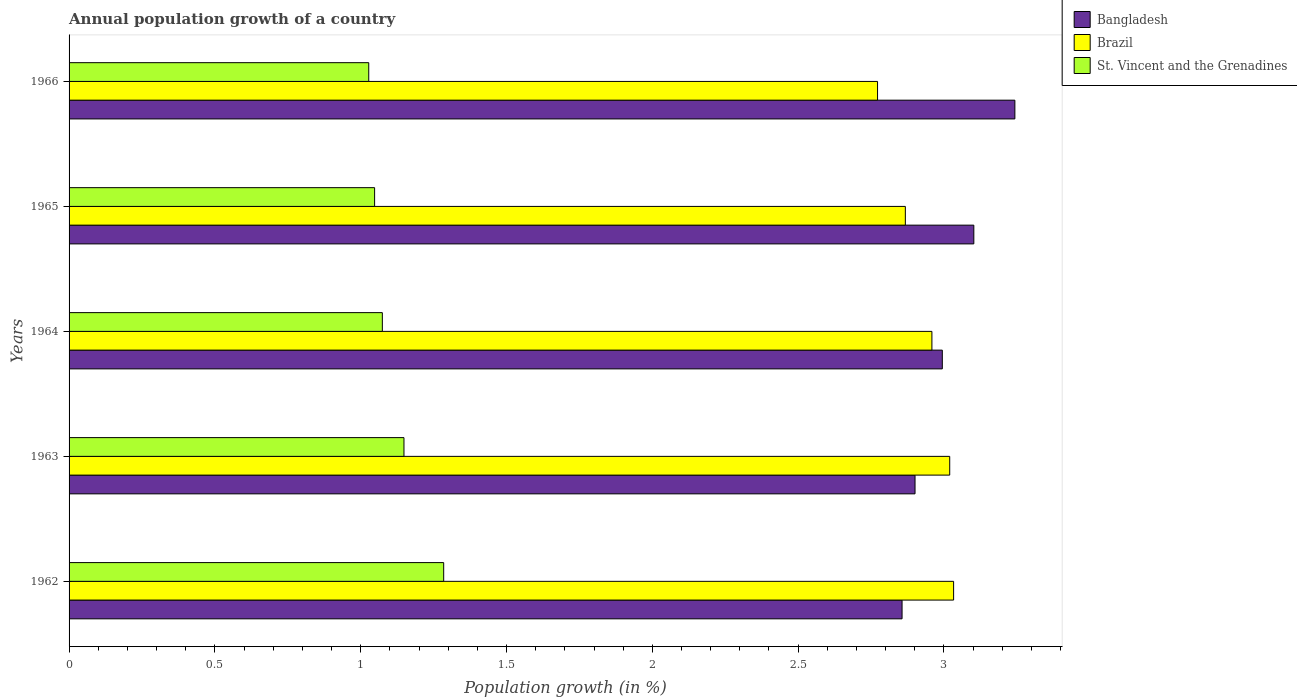How many groups of bars are there?
Keep it short and to the point. 5. Are the number of bars per tick equal to the number of legend labels?
Your answer should be compact. Yes. How many bars are there on the 4th tick from the top?
Your response must be concise. 3. What is the label of the 2nd group of bars from the top?
Give a very brief answer. 1965. In how many cases, is the number of bars for a given year not equal to the number of legend labels?
Keep it short and to the point. 0. What is the annual population growth in Brazil in 1965?
Keep it short and to the point. 2.87. Across all years, what is the maximum annual population growth in Brazil?
Provide a short and direct response. 3.03. Across all years, what is the minimum annual population growth in St. Vincent and the Grenadines?
Provide a succinct answer. 1.03. In which year was the annual population growth in Brazil minimum?
Your answer should be very brief. 1966. What is the total annual population growth in St. Vincent and the Grenadines in the graph?
Your response must be concise. 5.58. What is the difference between the annual population growth in Bangladesh in 1962 and that in 1965?
Make the answer very short. -0.25. What is the difference between the annual population growth in St. Vincent and the Grenadines in 1966 and the annual population growth in Bangladesh in 1963?
Ensure brevity in your answer.  -1.87. What is the average annual population growth in Bangladesh per year?
Offer a very short reply. 3.02. In the year 1962, what is the difference between the annual population growth in St. Vincent and the Grenadines and annual population growth in Brazil?
Offer a terse response. -1.75. What is the ratio of the annual population growth in St. Vincent and the Grenadines in 1963 to that in 1966?
Ensure brevity in your answer.  1.12. Is the annual population growth in Brazil in 1962 less than that in 1964?
Provide a succinct answer. No. What is the difference between the highest and the second highest annual population growth in Brazil?
Your answer should be compact. 0.01. What is the difference between the highest and the lowest annual population growth in Bangladesh?
Your answer should be compact. 0.39. In how many years, is the annual population growth in St. Vincent and the Grenadines greater than the average annual population growth in St. Vincent and the Grenadines taken over all years?
Ensure brevity in your answer.  2. What does the 3rd bar from the bottom in 1965 represents?
Keep it short and to the point. St. Vincent and the Grenadines. Is it the case that in every year, the sum of the annual population growth in Brazil and annual population growth in St. Vincent and the Grenadines is greater than the annual population growth in Bangladesh?
Offer a very short reply. Yes. How many bars are there?
Make the answer very short. 15. How many years are there in the graph?
Give a very brief answer. 5. What is the difference between two consecutive major ticks on the X-axis?
Your answer should be very brief. 0.5. Are the values on the major ticks of X-axis written in scientific E-notation?
Your response must be concise. No. Does the graph contain grids?
Offer a very short reply. No. Where does the legend appear in the graph?
Your response must be concise. Top right. How many legend labels are there?
Offer a very short reply. 3. What is the title of the graph?
Make the answer very short. Annual population growth of a country. Does "Virgin Islands" appear as one of the legend labels in the graph?
Keep it short and to the point. No. What is the label or title of the X-axis?
Your answer should be compact. Population growth (in %). What is the label or title of the Y-axis?
Your response must be concise. Years. What is the Population growth (in %) of Bangladesh in 1962?
Your response must be concise. 2.86. What is the Population growth (in %) of Brazil in 1962?
Give a very brief answer. 3.03. What is the Population growth (in %) of St. Vincent and the Grenadines in 1962?
Give a very brief answer. 1.28. What is the Population growth (in %) in Bangladesh in 1963?
Offer a very short reply. 2.9. What is the Population growth (in %) of Brazil in 1963?
Your answer should be compact. 3.02. What is the Population growth (in %) in St. Vincent and the Grenadines in 1963?
Offer a terse response. 1.15. What is the Population growth (in %) in Bangladesh in 1964?
Your response must be concise. 2.99. What is the Population growth (in %) in Brazil in 1964?
Provide a succinct answer. 2.96. What is the Population growth (in %) of St. Vincent and the Grenadines in 1964?
Your answer should be very brief. 1.07. What is the Population growth (in %) of Bangladesh in 1965?
Give a very brief answer. 3.1. What is the Population growth (in %) of Brazil in 1965?
Give a very brief answer. 2.87. What is the Population growth (in %) in St. Vincent and the Grenadines in 1965?
Your answer should be compact. 1.05. What is the Population growth (in %) of Bangladesh in 1966?
Ensure brevity in your answer.  3.24. What is the Population growth (in %) in Brazil in 1966?
Offer a very short reply. 2.77. What is the Population growth (in %) in St. Vincent and the Grenadines in 1966?
Offer a very short reply. 1.03. Across all years, what is the maximum Population growth (in %) in Bangladesh?
Provide a short and direct response. 3.24. Across all years, what is the maximum Population growth (in %) in Brazil?
Your response must be concise. 3.03. Across all years, what is the maximum Population growth (in %) in St. Vincent and the Grenadines?
Keep it short and to the point. 1.28. Across all years, what is the minimum Population growth (in %) in Bangladesh?
Offer a very short reply. 2.86. Across all years, what is the minimum Population growth (in %) in Brazil?
Your answer should be compact. 2.77. Across all years, what is the minimum Population growth (in %) of St. Vincent and the Grenadines?
Ensure brevity in your answer.  1.03. What is the total Population growth (in %) in Bangladesh in the graph?
Keep it short and to the point. 15.1. What is the total Population growth (in %) of Brazil in the graph?
Keep it short and to the point. 14.65. What is the total Population growth (in %) of St. Vincent and the Grenadines in the graph?
Provide a succinct answer. 5.58. What is the difference between the Population growth (in %) in Bangladesh in 1962 and that in 1963?
Your response must be concise. -0.04. What is the difference between the Population growth (in %) in Brazil in 1962 and that in 1963?
Provide a short and direct response. 0.01. What is the difference between the Population growth (in %) in St. Vincent and the Grenadines in 1962 and that in 1963?
Offer a very short reply. 0.14. What is the difference between the Population growth (in %) of Bangladesh in 1962 and that in 1964?
Offer a very short reply. -0.14. What is the difference between the Population growth (in %) in Brazil in 1962 and that in 1964?
Give a very brief answer. 0.07. What is the difference between the Population growth (in %) in St. Vincent and the Grenadines in 1962 and that in 1964?
Offer a terse response. 0.21. What is the difference between the Population growth (in %) in Bangladesh in 1962 and that in 1965?
Provide a short and direct response. -0.25. What is the difference between the Population growth (in %) in Brazil in 1962 and that in 1965?
Provide a succinct answer. 0.17. What is the difference between the Population growth (in %) in St. Vincent and the Grenadines in 1962 and that in 1965?
Make the answer very short. 0.24. What is the difference between the Population growth (in %) in Bangladesh in 1962 and that in 1966?
Your answer should be compact. -0.39. What is the difference between the Population growth (in %) of Brazil in 1962 and that in 1966?
Your answer should be compact. 0.26. What is the difference between the Population growth (in %) of St. Vincent and the Grenadines in 1962 and that in 1966?
Provide a short and direct response. 0.26. What is the difference between the Population growth (in %) in Bangladesh in 1963 and that in 1964?
Your answer should be compact. -0.09. What is the difference between the Population growth (in %) of Brazil in 1963 and that in 1964?
Offer a terse response. 0.06. What is the difference between the Population growth (in %) in St. Vincent and the Grenadines in 1963 and that in 1964?
Offer a terse response. 0.07. What is the difference between the Population growth (in %) in Bangladesh in 1963 and that in 1965?
Give a very brief answer. -0.2. What is the difference between the Population growth (in %) of Brazil in 1963 and that in 1965?
Provide a short and direct response. 0.15. What is the difference between the Population growth (in %) in St. Vincent and the Grenadines in 1963 and that in 1965?
Provide a short and direct response. 0.1. What is the difference between the Population growth (in %) in Bangladesh in 1963 and that in 1966?
Your answer should be compact. -0.34. What is the difference between the Population growth (in %) of Brazil in 1963 and that in 1966?
Provide a short and direct response. 0.25. What is the difference between the Population growth (in %) of St. Vincent and the Grenadines in 1963 and that in 1966?
Offer a very short reply. 0.12. What is the difference between the Population growth (in %) of Bangladesh in 1964 and that in 1965?
Offer a terse response. -0.11. What is the difference between the Population growth (in %) in Brazil in 1964 and that in 1965?
Your answer should be very brief. 0.09. What is the difference between the Population growth (in %) of St. Vincent and the Grenadines in 1964 and that in 1965?
Make the answer very short. 0.03. What is the difference between the Population growth (in %) of Bangladesh in 1964 and that in 1966?
Offer a terse response. -0.25. What is the difference between the Population growth (in %) of Brazil in 1964 and that in 1966?
Your answer should be compact. 0.19. What is the difference between the Population growth (in %) in St. Vincent and the Grenadines in 1964 and that in 1966?
Provide a short and direct response. 0.05. What is the difference between the Population growth (in %) of Bangladesh in 1965 and that in 1966?
Offer a very short reply. -0.14. What is the difference between the Population growth (in %) in Brazil in 1965 and that in 1966?
Provide a short and direct response. 0.1. What is the difference between the Population growth (in %) in St. Vincent and the Grenadines in 1965 and that in 1966?
Offer a very short reply. 0.02. What is the difference between the Population growth (in %) of Bangladesh in 1962 and the Population growth (in %) of Brazil in 1963?
Provide a short and direct response. -0.16. What is the difference between the Population growth (in %) of Bangladesh in 1962 and the Population growth (in %) of St. Vincent and the Grenadines in 1963?
Your answer should be very brief. 1.71. What is the difference between the Population growth (in %) of Brazil in 1962 and the Population growth (in %) of St. Vincent and the Grenadines in 1963?
Offer a very short reply. 1.88. What is the difference between the Population growth (in %) of Bangladesh in 1962 and the Population growth (in %) of Brazil in 1964?
Provide a short and direct response. -0.1. What is the difference between the Population growth (in %) in Bangladesh in 1962 and the Population growth (in %) in St. Vincent and the Grenadines in 1964?
Ensure brevity in your answer.  1.78. What is the difference between the Population growth (in %) of Brazil in 1962 and the Population growth (in %) of St. Vincent and the Grenadines in 1964?
Your answer should be very brief. 1.96. What is the difference between the Population growth (in %) in Bangladesh in 1962 and the Population growth (in %) in Brazil in 1965?
Your response must be concise. -0.01. What is the difference between the Population growth (in %) in Bangladesh in 1962 and the Population growth (in %) in St. Vincent and the Grenadines in 1965?
Your response must be concise. 1.81. What is the difference between the Population growth (in %) of Brazil in 1962 and the Population growth (in %) of St. Vincent and the Grenadines in 1965?
Provide a short and direct response. 1.99. What is the difference between the Population growth (in %) of Bangladesh in 1962 and the Population growth (in %) of Brazil in 1966?
Your answer should be compact. 0.08. What is the difference between the Population growth (in %) of Bangladesh in 1962 and the Population growth (in %) of St. Vincent and the Grenadines in 1966?
Your answer should be very brief. 1.83. What is the difference between the Population growth (in %) in Brazil in 1962 and the Population growth (in %) in St. Vincent and the Grenadines in 1966?
Your answer should be very brief. 2.01. What is the difference between the Population growth (in %) of Bangladesh in 1963 and the Population growth (in %) of Brazil in 1964?
Provide a short and direct response. -0.06. What is the difference between the Population growth (in %) in Bangladesh in 1963 and the Population growth (in %) in St. Vincent and the Grenadines in 1964?
Give a very brief answer. 1.83. What is the difference between the Population growth (in %) in Brazil in 1963 and the Population growth (in %) in St. Vincent and the Grenadines in 1964?
Your response must be concise. 1.95. What is the difference between the Population growth (in %) in Bangladesh in 1963 and the Population growth (in %) in Brazil in 1965?
Give a very brief answer. 0.03. What is the difference between the Population growth (in %) of Bangladesh in 1963 and the Population growth (in %) of St. Vincent and the Grenadines in 1965?
Provide a short and direct response. 1.85. What is the difference between the Population growth (in %) of Brazil in 1963 and the Population growth (in %) of St. Vincent and the Grenadines in 1965?
Provide a succinct answer. 1.97. What is the difference between the Population growth (in %) in Bangladesh in 1963 and the Population growth (in %) in Brazil in 1966?
Give a very brief answer. 0.13. What is the difference between the Population growth (in %) in Bangladesh in 1963 and the Population growth (in %) in St. Vincent and the Grenadines in 1966?
Keep it short and to the point. 1.87. What is the difference between the Population growth (in %) of Brazil in 1963 and the Population growth (in %) of St. Vincent and the Grenadines in 1966?
Offer a terse response. 1.99. What is the difference between the Population growth (in %) of Bangladesh in 1964 and the Population growth (in %) of Brazil in 1965?
Give a very brief answer. 0.13. What is the difference between the Population growth (in %) of Bangladesh in 1964 and the Population growth (in %) of St. Vincent and the Grenadines in 1965?
Make the answer very short. 1.95. What is the difference between the Population growth (in %) of Brazil in 1964 and the Population growth (in %) of St. Vincent and the Grenadines in 1965?
Provide a succinct answer. 1.91. What is the difference between the Population growth (in %) of Bangladesh in 1964 and the Population growth (in %) of Brazil in 1966?
Offer a very short reply. 0.22. What is the difference between the Population growth (in %) of Bangladesh in 1964 and the Population growth (in %) of St. Vincent and the Grenadines in 1966?
Your answer should be compact. 1.97. What is the difference between the Population growth (in %) of Brazil in 1964 and the Population growth (in %) of St. Vincent and the Grenadines in 1966?
Your response must be concise. 1.93. What is the difference between the Population growth (in %) in Bangladesh in 1965 and the Population growth (in %) in Brazil in 1966?
Offer a very short reply. 0.33. What is the difference between the Population growth (in %) of Bangladesh in 1965 and the Population growth (in %) of St. Vincent and the Grenadines in 1966?
Give a very brief answer. 2.07. What is the difference between the Population growth (in %) of Brazil in 1965 and the Population growth (in %) of St. Vincent and the Grenadines in 1966?
Give a very brief answer. 1.84. What is the average Population growth (in %) of Bangladesh per year?
Provide a succinct answer. 3.02. What is the average Population growth (in %) of Brazil per year?
Keep it short and to the point. 2.93. What is the average Population growth (in %) of St. Vincent and the Grenadines per year?
Keep it short and to the point. 1.12. In the year 1962, what is the difference between the Population growth (in %) in Bangladesh and Population growth (in %) in Brazil?
Offer a terse response. -0.18. In the year 1962, what is the difference between the Population growth (in %) in Bangladesh and Population growth (in %) in St. Vincent and the Grenadines?
Give a very brief answer. 1.57. In the year 1962, what is the difference between the Population growth (in %) in Brazil and Population growth (in %) in St. Vincent and the Grenadines?
Offer a terse response. 1.75. In the year 1963, what is the difference between the Population growth (in %) of Bangladesh and Population growth (in %) of Brazil?
Your response must be concise. -0.12. In the year 1963, what is the difference between the Population growth (in %) of Bangladesh and Population growth (in %) of St. Vincent and the Grenadines?
Your answer should be compact. 1.75. In the year 1963, what is the difference between the Population growth (in %) in Brazil and Population growth (in %) in St. Vincent and the Grenadines?
Keep it short and to the point. 1.87. In the year 1964, what is the difference between the Population growth (in %) of Bangladesh and Population growth (in %) of Brazil?
Keep it short and to the point. 0.04. In the year 1964, what is the difference between the Population growth (in %) in Bangladesh and Population growth (in %) in St. Vincent and the Grenadines?
Provide a short and direct response. 1.92. In the year 1964, what is the difference between the Population growth (in %) of Brazil and Population growth (in %) of St. Vincent and the Grenadines?
Your answer should be very brief. 1.88. In the year 1965, what is the difference between the Population growth (in %) of Bangladesh and Population growth (in %) of Brazil?
Your response must be concise. 0.23. In the year 1965, what is the difference between the Population growth (in %) in Bangladesh and Population growth (in %) in St. Vincent and the Grenadines?
Give a very brief answer. 2.05. In the year 1965, what is the difference between the Population growth (in %) of Brazil and Population growth (in %) of St. Vincent and the Grenadines?
Your answer should be very brief. 1.82. In the year 1966, what is the difference between the Population growth (in %) in Bangladesh and Population growth (in %) in Brazil?
Give a very brief answer. 0.47. In the year 1966, what is the difference between the Population growth (in %) in Bangladesh and Population growth (in %) in St. Vincent and the Grenadines?
Provide a short and direct response. 2.22. In the year 1966, what is the difference between the Population growth (in %) in Brazil and Population growth (in %) in St. Vincent and the Grenadines?
Offer a terse response. 1.74. What is the ratio of the Population growth (in %) of Bangladesh in 1962 to that in 1963?
Offer a terse response. 0.98. What is the ratio of the Population growth (in %) of St. Vincent and the Grenadines in 1962 to that in 1963?
Ensure brevity in your answer.  1.12. What is the ratio of the Population growth (in %) of Bangladesh in 1962 to that in 1964?
Offer a very short reply. 0.95. What is the ratio of the Population growth (in %) of Brazil in 1962 to that in 1964?
Give a very brief answer. 1.03. What is the ratio of the Population growth (in %) in St. Vincent and the Grenadines in 1962 to that in 1964?
Your answer should be compact. 1.2. What is the ratio of the Population growth (in %) in Bangladesh in 1962 to that in 1965?
Offer a terse response. 0.92. What is the ratio of the Population growth (in %) of Brazil in 1962 to that in 1965?
Your answer should be very brief. 1.06. What is the ratio of the Population growth (in %) of St. Vincent and the Grenadines in 1962 to that in 1965?
Provide a succinct answer. 1.23. What is the ratio of the Population growth (in %) of Bangladesh in 1962 to that in 1966?
Your answer should be compact. 0.88. What is the ratio of the Population growth (in %) of Brazil in 1962 to that in 1966?
Your answer should be compact. 1.09. What is the ratio of the Population growth (in %) in St. Vincent and the Grenadines in 1962 to that in 1966?
Ensure brevity in your answer.  1.25. What is the ratio of the Population growth (in %) in Bangladesh in 1963 to that in 1964?
Offer a terse response. 0.97. What is the ratio of the Population growth (in %) of Brazil in 1963 to that in 1964?
Provide a succinct answer. 1.02. What is the ratio of the Population growth (in %) of St. Vincent and the Grenadines in 1963 to that in 1964?
Provide a short and direct response. 1.07. What is the ratio of the Population growth (in %) of Bangladesh in 1963 to that in 1965?
Your response must be concise. 0.94. What is the ratio of the Population growth (in %) in Brazil in 1963 to that in 1965?
Offer a very short reply. 1.05. What is the ratio of the Population growth (in %) of St. Vincent and the Grenadines in 1963 to that in 1965?
Provide a short and direct response. 1.1. What is the ratio of the Population growth (in %) of Bangladesh in 1963 to that in 1966?
Ensure brevity in your answer.  0.89. What is the ratio of the Population growth (in %) in Brazil in 1963 to that in 1966?
Keep it short and to the point. 1.09. What is the ratio of the Population growth (in %) in St. Vincent and the Grenadines in 1963 to that in 1966?
Offer a terse response. 1.12. What is the ratio of the Population growth (in %) of Bangladesh in 1964 to that in 1965?
Your response must be concise. 0.97. What is the ratio of the Population growth (in %) of Brazil in 1964 to that in 1965?
Provide a succinct answer. 1.03. What is the ratio of the Population growth (in %) in St. Vincent and the Grenadines in 1964 to that in 1965?
Your answer should be compact. 1.03. What is the ratio of the Population growth (in %) in Bangladesh in 1964 to that in 1966?
Ensure brevity in your answer.  0.92. What is the ratio of the Population growth (in %) of Brazil in 1964 to that in 1966?
Provide a short and direct response. 1.07. What is the ratio of the Population growth (in %) of St. Vincent and the Grenadines in 1964 to that in 1966?
Provide a short and direct response. 1.05. What is the ratio of the Population growth (in %) of Bangladesh in 1965 to that in 1966?
Your response must be concise. 0.96. What is the ratio of the Population growth (in %) in Brazil in 1965 to that in 1966?
Provide a succinct answer. 1.03. What is the ratio of the Population growth (in %) of St. Vincent and the Grenadines in 1965 to that in 1966?
Make the answer very short. 1.02. What is the difference between the highest and the second highest Population growth (in %) in Bangladesh?
Make the answer very short. 0.14. What is the difference between the highest and the second highest Population growth (in %) of Brazil?
Keep it short and to the point. 0.01. What is the difference between the highest and the second highest Population growth (in %) in St. Vincent and the Grenadines?
Your response must be concise. 0.14. What is the difference between the highest and the lowest Population growth (in %) in Bangladesh?
Provide a succinct answer. 0.39. What is the difference between the highest and the lowest Population growth (in %) in Brazil?
Give a very brief answer. 0.26. What is the difference between the highest and the lowest Population growth (in %) of St. Vincent and the Grenadines?
Ensure brevity in your answer.  0.26. 